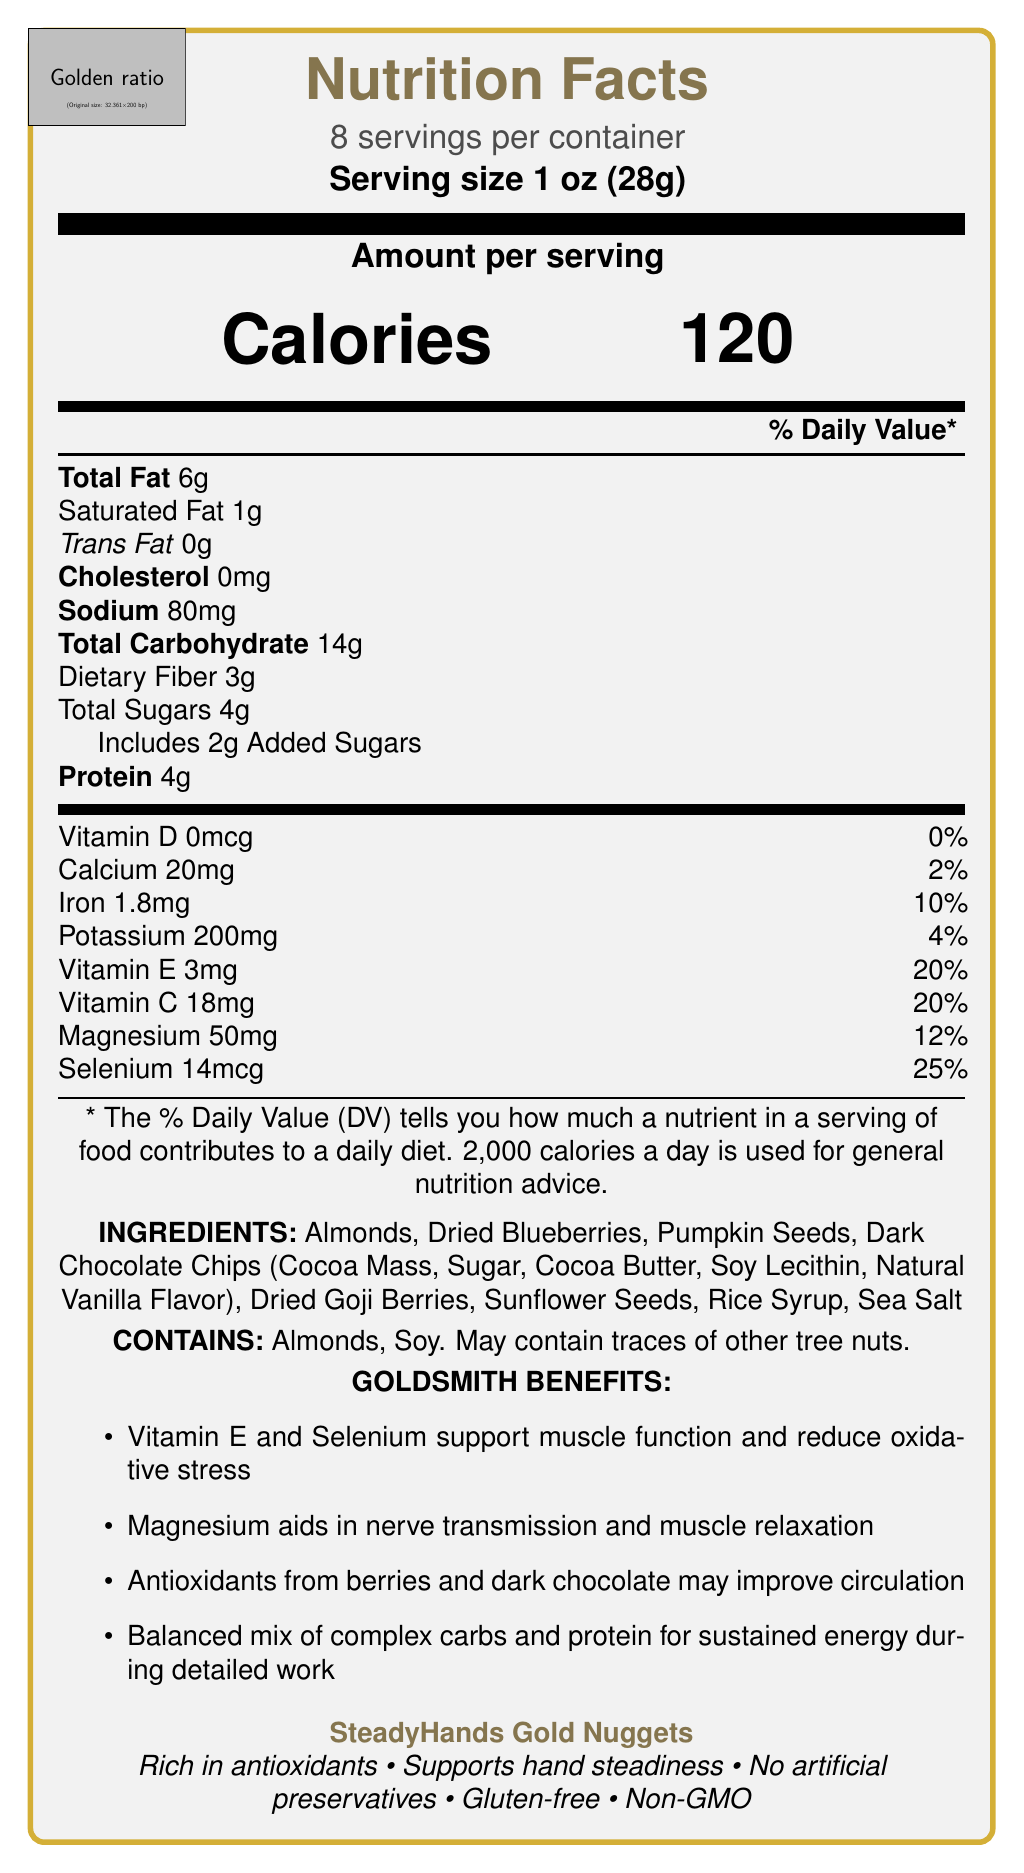What is the serving size of the product? The serving size is clearly listed as "1 oz (28g)" in the document.
Answer: 1 oz (28g) How many calories are in one serving of SteadyHands Gold Nuggets? The number of calories per serving is highlighted as "120 Calories" in the document.
Answer: 120 What percentage of the daily value of dietary fiber does one serving provide? The document states that dietary fiber contributes 11% of the daily value per serving.
Answer: 11% What are the primary ingredients in SteadyHands Gold Nuggets? The ingredients are listed clearly in the document.
Answer: Almonds, Dried Blueberries, Pumpkin Seeds, Dark Chocolate Chips, Dried Goji Berries, Sunflower Seeds, Rice Syrup, Sea Salt Does SteadyHands Gold Nuggets contain any allergens? The document indicates that the product contains almonds and soy, and may contain traces of other tree nuts.
Answer: Yes Which vitamin has the highest percentage of daily value per serving? A. Vitamin D B. Vitamin E C. Vitamin C D. Selenium Selenium provides 25% of the daily value, which is higher than other listed vitamins.
Answer: D What is the amount of sodium per serving? A. 60mg B. 70mg C. 80mg D. 90mg The amount of sodium is 80mg per serving as indicated in the document.
Answer: C True or False: SteadyHands Gold Nuggets include artificial preservatives. The document claims that the product contains "No artificial preservatives."
Answer: False Summarize the intended benefits of SteadyHands Gold Nuggets for goldsmiths. The document details that the product is rich in antioxidants, supports hand steadiness, and includes specific nutrients like Vitamin E, Selenium, and Magnesium that support muscle function and nerve transmission, ultimately aiding detailed work for goldsmiths.
Answer: SteadyHands Gold Nuggets aim to improve hand steadiness for goldsmiths by providing antioxidants, vitamins, minerals, and a balance of complex carbs and protein, which support muscle function, reduce oxidative stress, aid nerve transmission, and provide sustained energy. How many grams of protein are in one serving? The document specifies that there are 4 grams of protein per serving.
Answer: 4g What is the name of the product? The product name is prominently displayed as "SteadyHands Gold Nuggets."
Answer: SteadyHands Gold Nuggets Can you determine the exact number of almonds included in one serving from the document? The document lists almonds as an ingredient but does not specify the exact number of almonds per serving.
Answer: Not enough information 